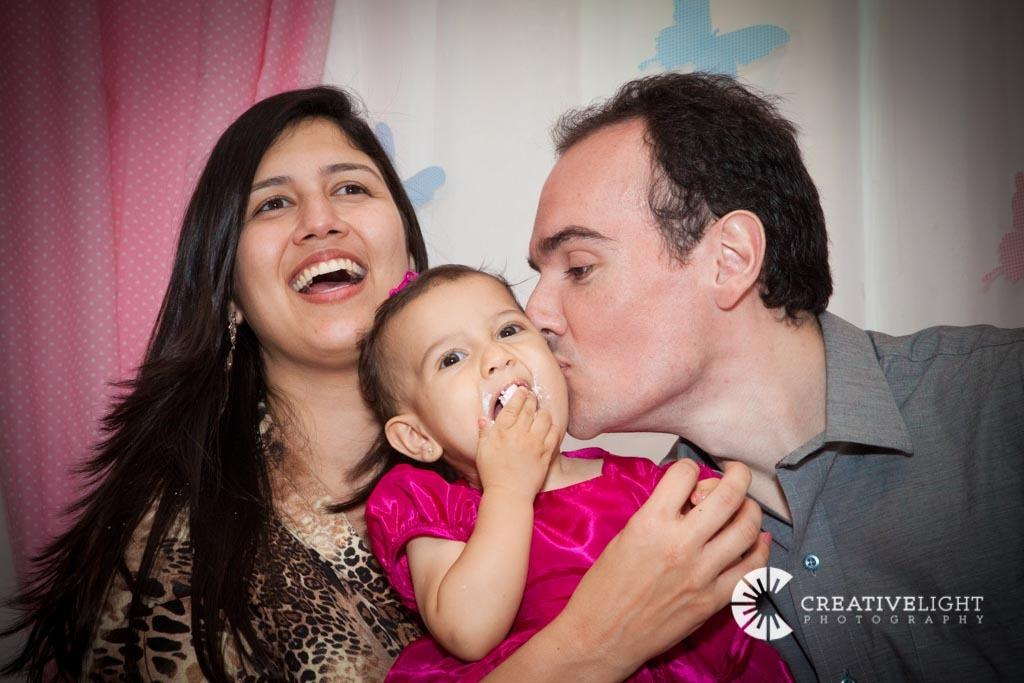Who are the people in the image? There is a man and a woman in the image. What is the man holding in the image? The man is holding a baby in the image. What can be seen in the background of the image? There is a wall and curtains in the background of the image. What type of writing can be seen on the vase in the image? There is no vase present in the image, so no writing can be seen on it. What is the coil used for in the image? There is no coil present in the image, so it cannot be used for anything in the context of the image. 